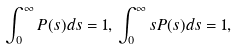<formula> <loc_0><loc_0><loc_500><loc_500>\int _ { 0 } ^ { \infty } P ( s ) d s = 1 , \, \int _ { 0 } ^ { \infty } s P ( s ) d s = 1 ,</formula> 